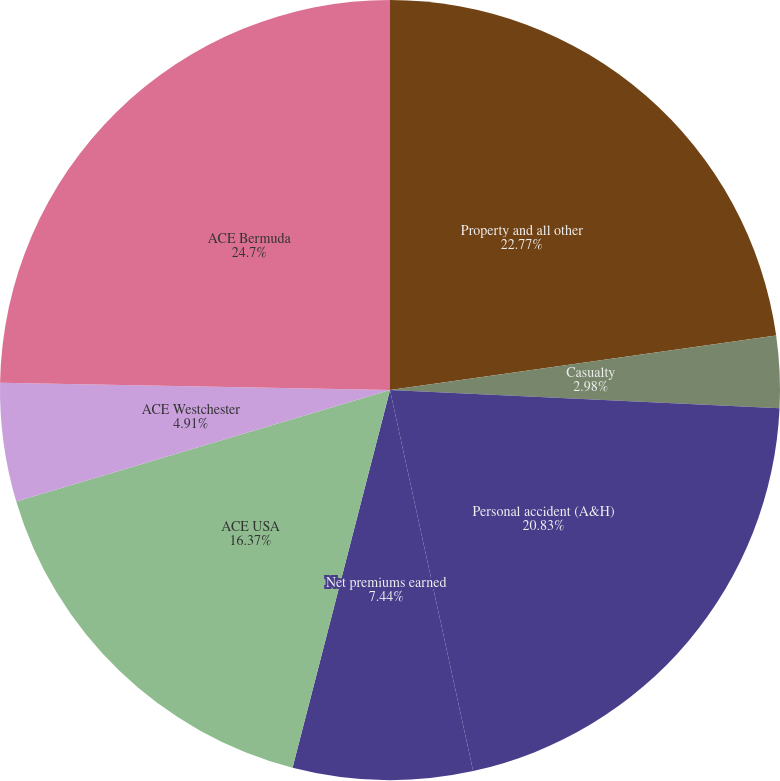Convert chart to OTSL. <chart><loc_0><loc_0><loc_500><loc_500><pie_chart><fcel>Property and all other<fcel>Casualty<fcel>Personal accident (A&H)<fcel>Net premiums earned<fcel>ACE USA<fcel>ACE Westchester<fcel>ACE Bermuda<nl><fcel>22.77%<fcel>2.98%<fcel>20.83%<fcel>7.44%<fcel>16.37%<fcel>4.91%<fcel>24.7%<nl></chart> 